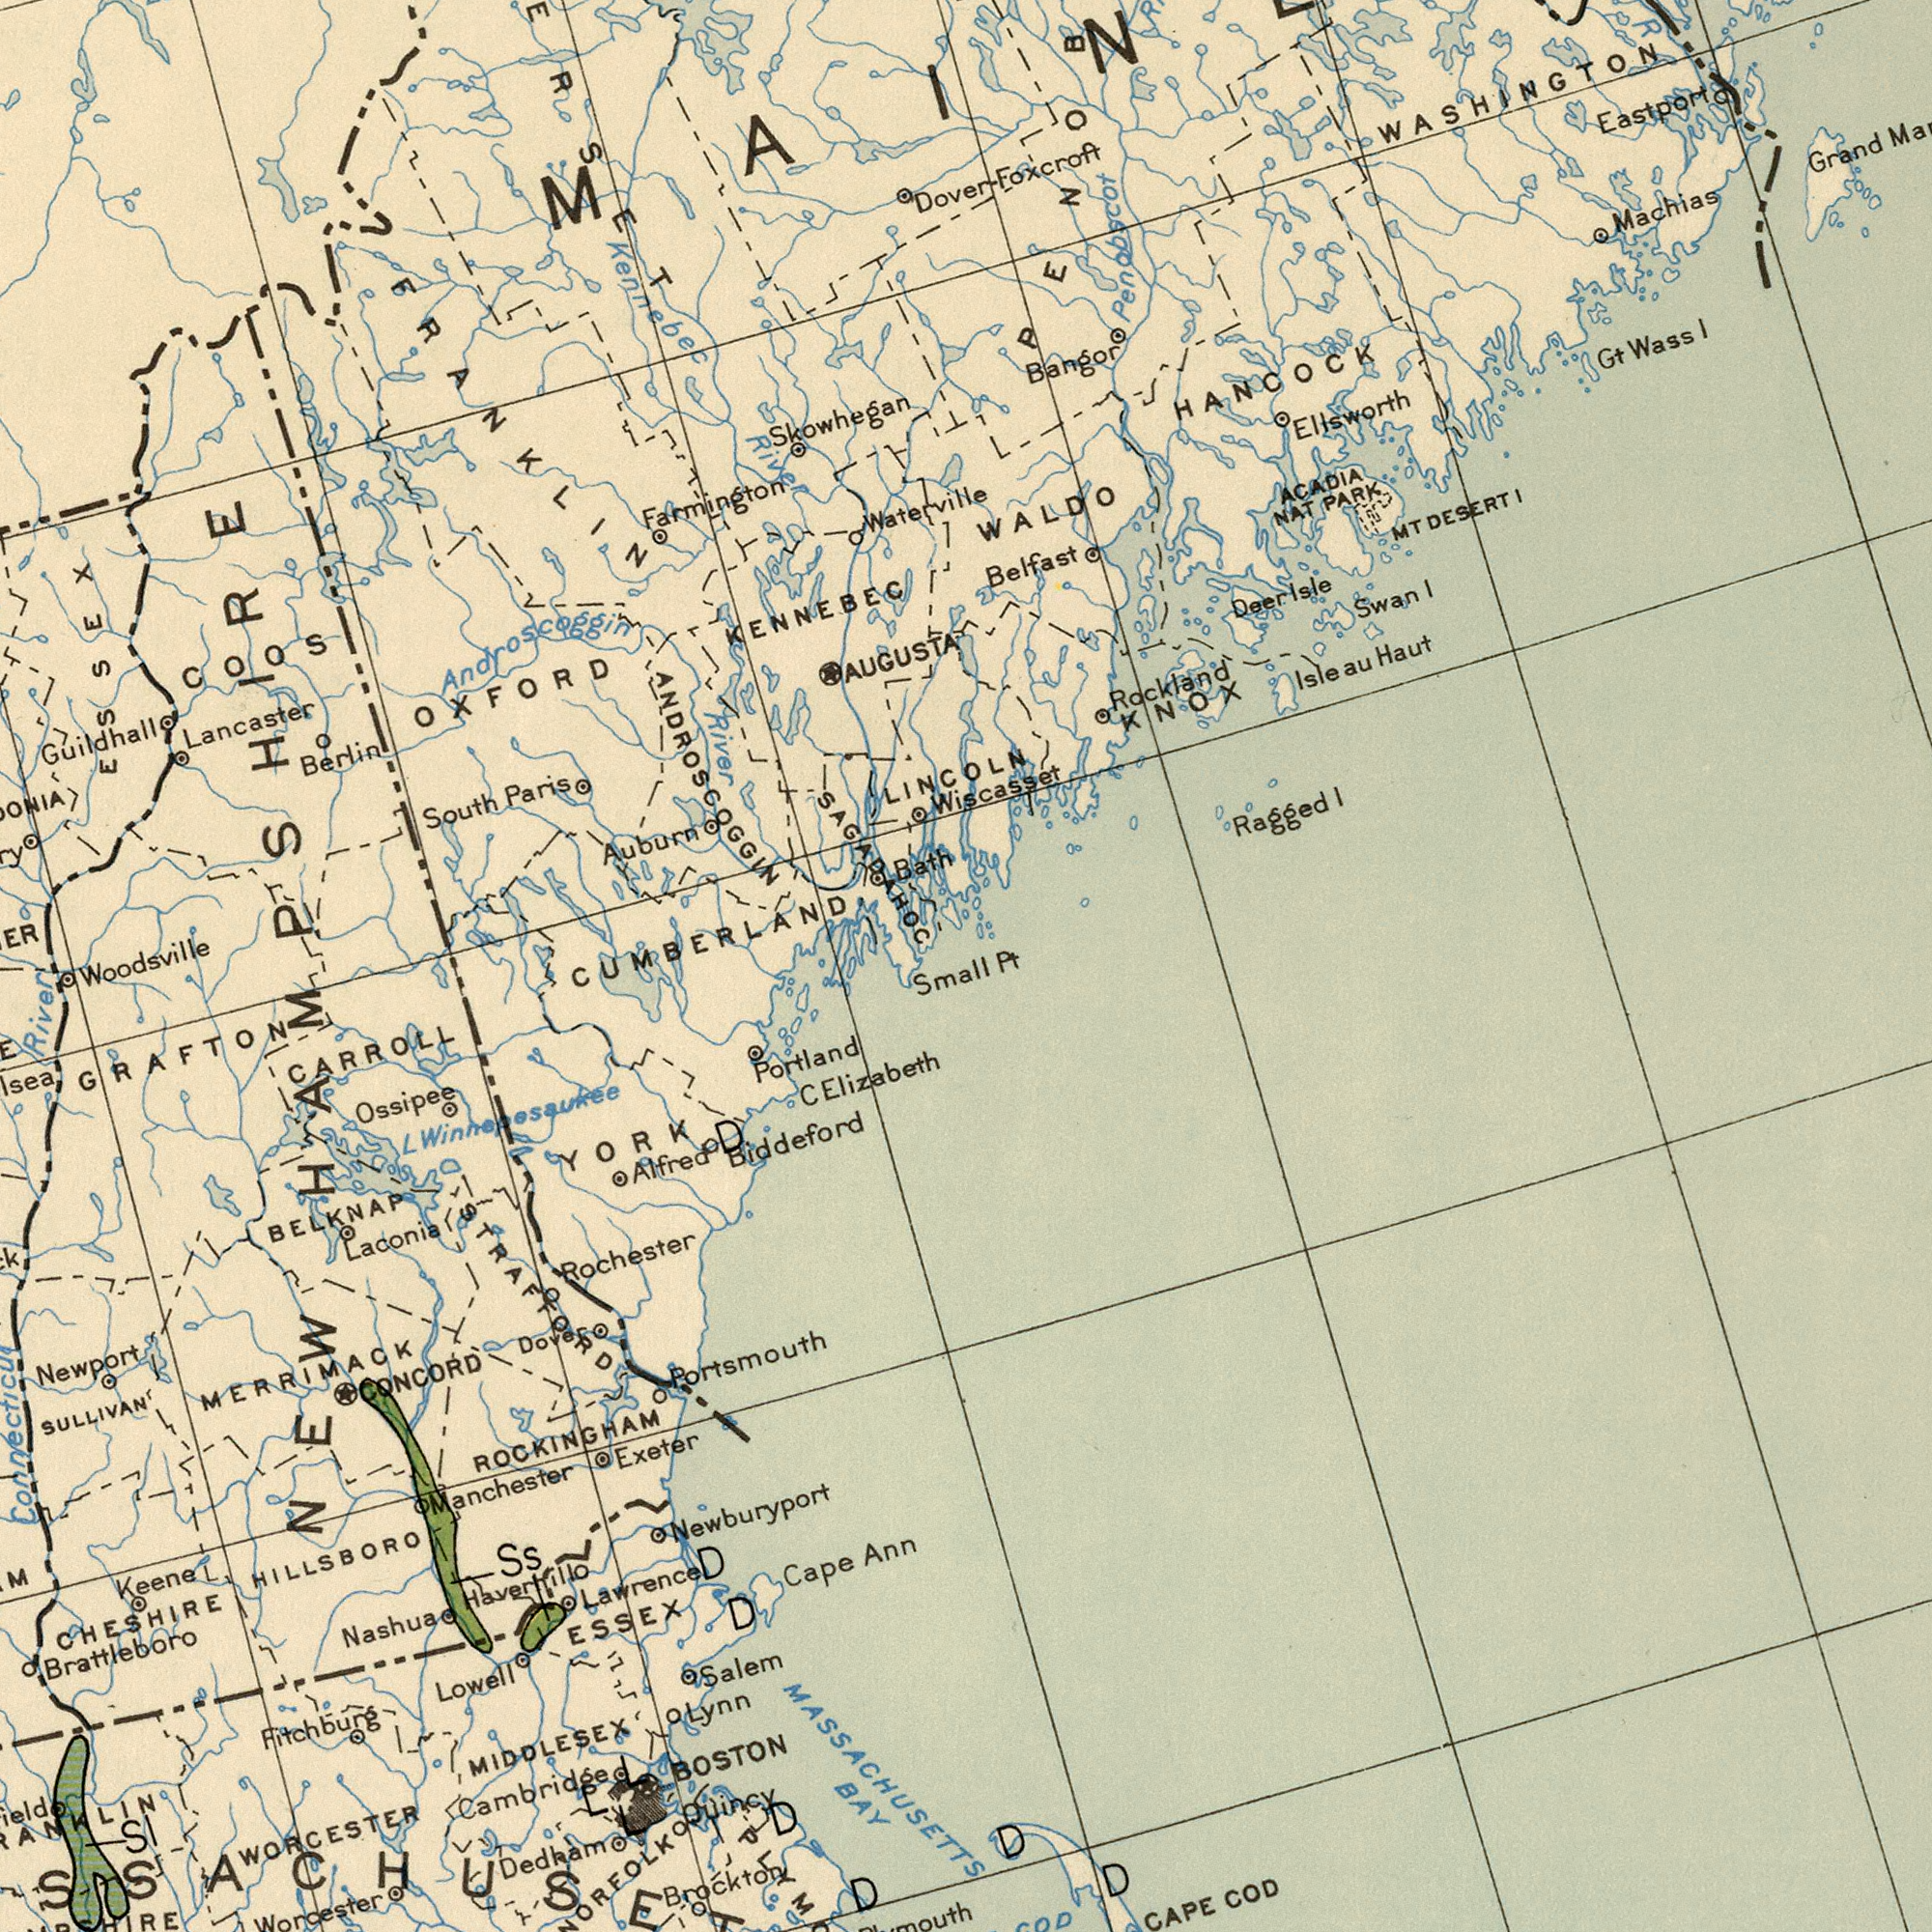What text is visible in the lower-right corner? COD CAPE D D What text can you see in the top-right section? LINCOLN Belfast Machias WASHINGTON Grand Eastport Ragged Wiscasset Ellsworth Bangor Deer WALDO Swan Rockland Penobscot Dover- Wass Gt Haut ACADIA NAT DESERT HANCOCK PARK KNOX Isleau I I Isle MT I I Foxcroft Pt What text is visible in the lower-left corner? ROCKINGHAM CARROLL SULLIVAN Newport C Nashua MERRIMACK Newburyport Ossipee MIDDLESEX Brattleboro Cambridge ESSEX Worcester Exeter BAY Ann Salem Keene River Portland Biddeford Laconia Brockton Rochester BELKNAP Fitchburg Cape Alfred HILLSBORO CONCORD Lowell WORCESTER Portsmouth Dedham BOSTON GRAFTON Lynn Ss MASSACHUSETTS Manchester Quincy CHESHIRE D D Winnepesaukee YORK D Lawrence Haverhill STRAFFORD Elizabeth D SI D NEW L Dover What text can you see in the top-left section? KENNEBEC AUGUSTA South Berlin Lancaster Paris Farmington Auburn Guildhall OXFORD CUMBERLAND River Bath Skowhegan River Waterville Woodsville Androscoggin ESSEX FRANKLIN SAGADAHOC ANDROSCOGGIN COOS Small HAMPSHIRE Kennebec 